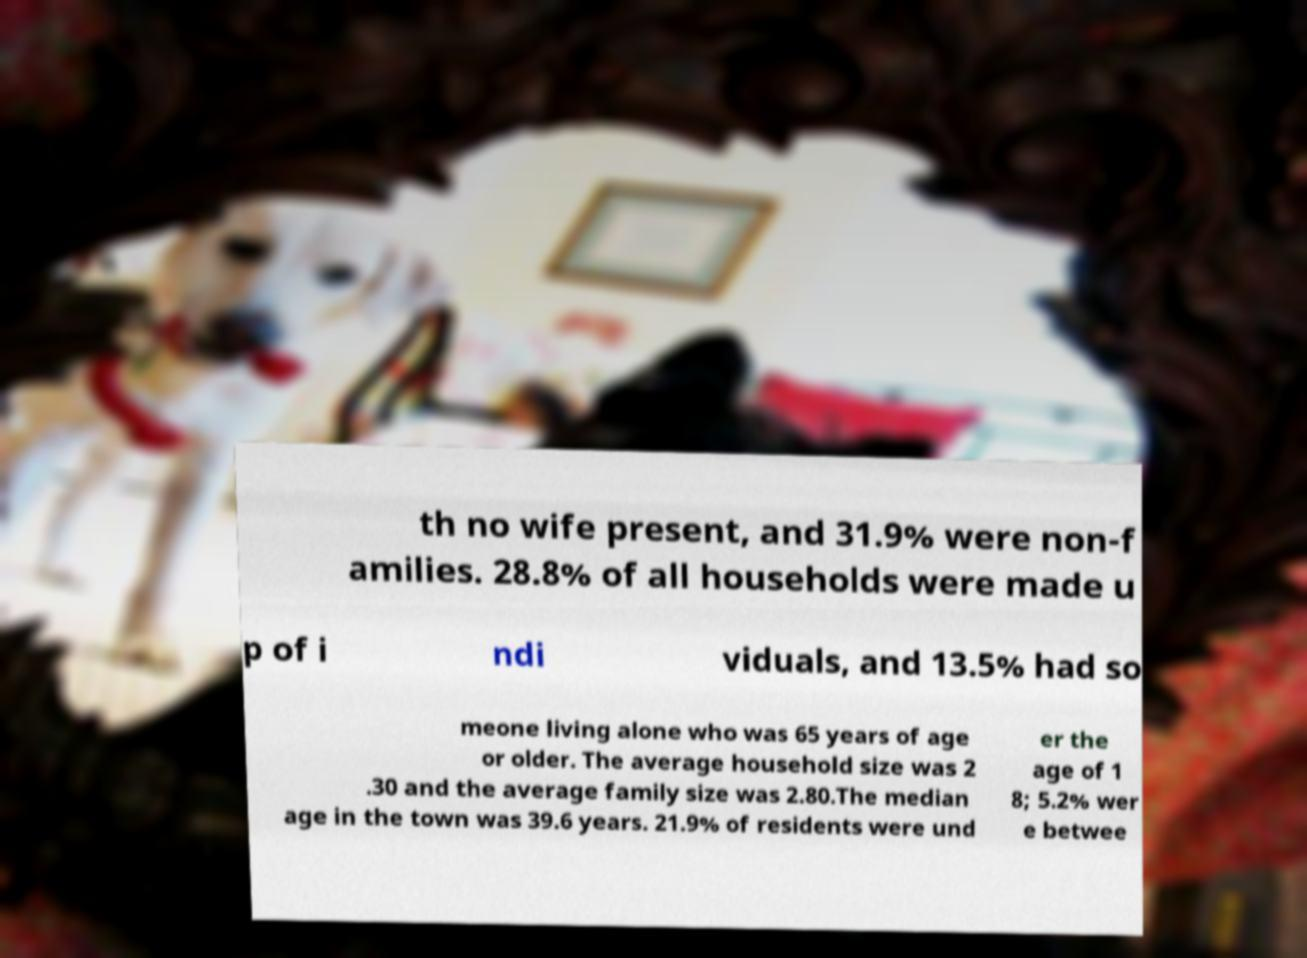Can you read and provide the text displayed in the image?This photo seems to have some interesting text. Can you extract and type it out for me? th no wife present, and 31.9% were non-f amilies. 28.8% of all households were made u p of i ndi viduals, and 13.5% had so meone living alone who was 65 years of age or older. The average household size was 2 .30 and the average family size was 2.80.The median age in the town was 39.6 years. 21.9% of residents were und er the age of 1 8; 5.2% wer e betwee 